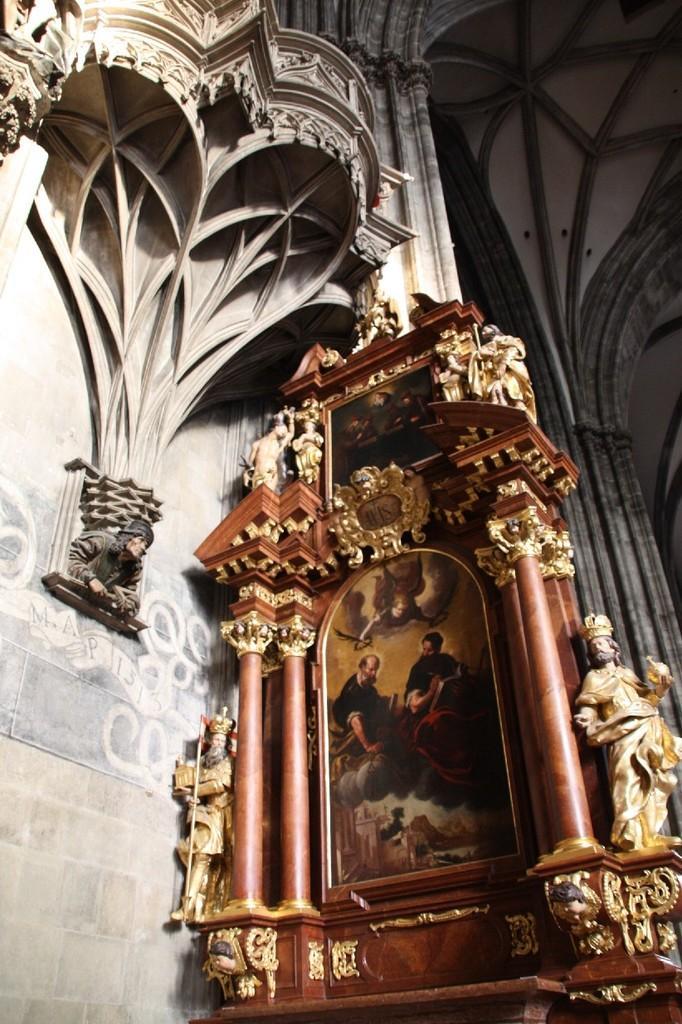In one or two sentences, can you explain what this image depicts? In the picture I can see a wall, sculptures and a painting. In the painting I can see people. The object is brown in color which has golden color sculptures attached to it. 